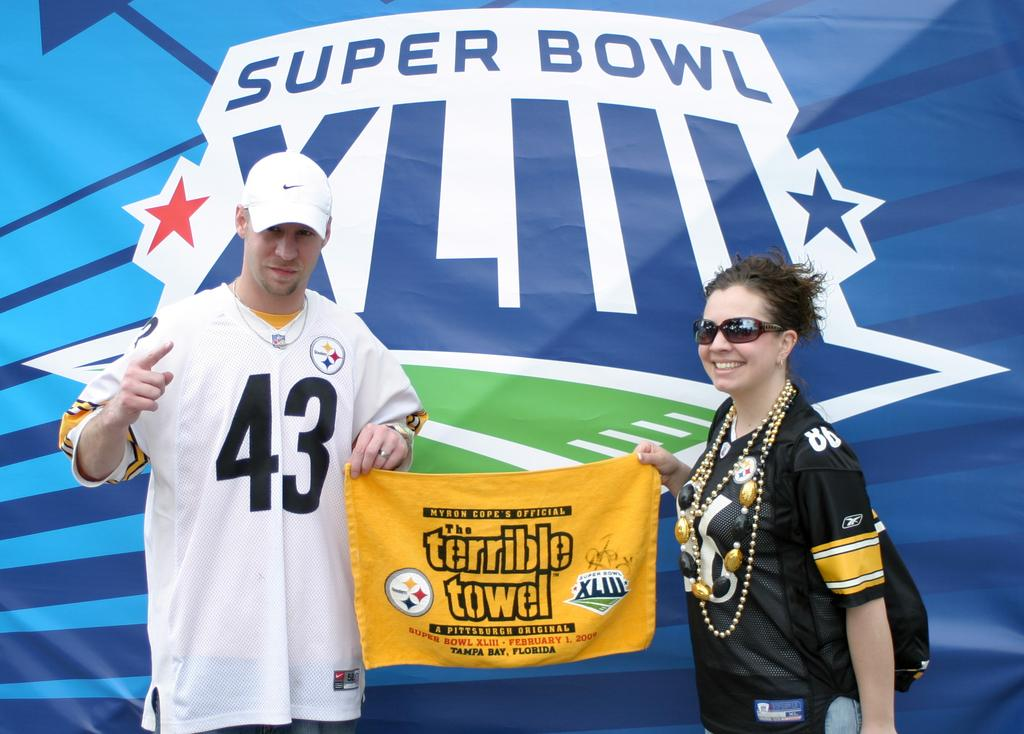<image>
Write a terse but informative summary of the picture. Two people hold up a yellow rag with the words Terrible Towel printed on it. 